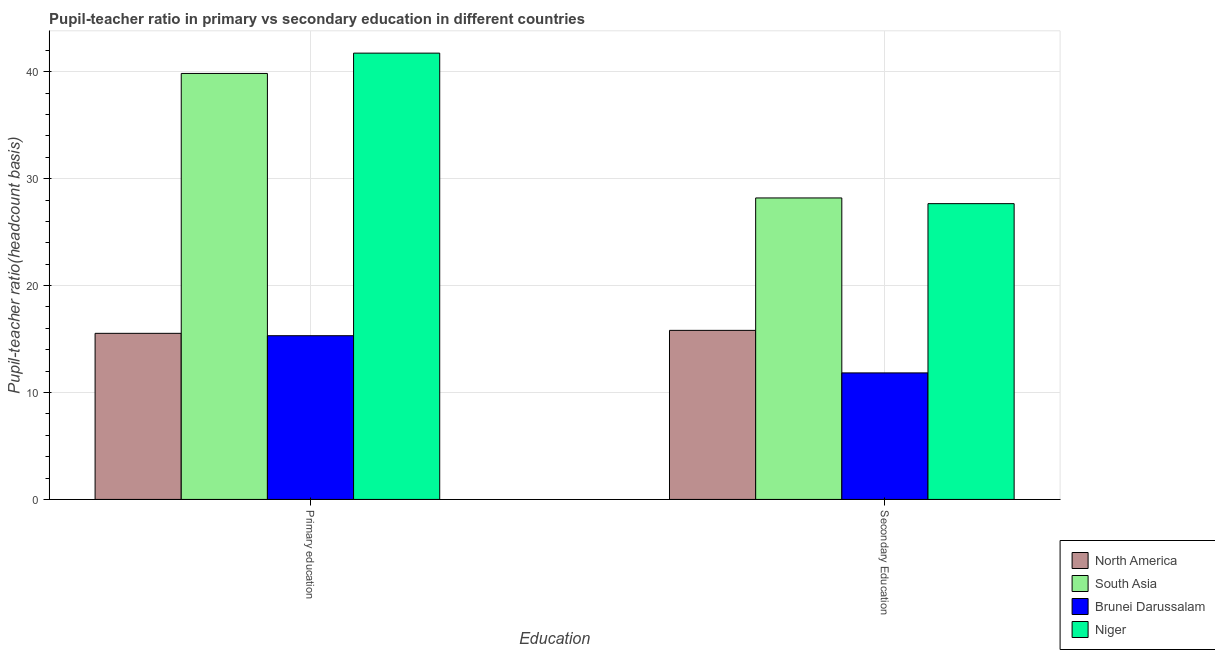Are the number of bars on each tick of the X-axis equal?
Provide a short and direct response. Yes. What is the label of the 2nd group of bars from the left?
Offer a terse response. Secondary Education. What is the pupil teacher ratio on secondary education in South Asia?
Keep it short and to the point. 28.19. Across all countries, what is the maximum pupil-teacher ratio in primary education?
Offer a terse response. 41.74. Across all countries, what is the minimum pupil teacher ratio on secondary education?
Give a very brief answer. 11.83. In which country was the pupil teacher ratio on secondary education minimum?
Provide a short and direct response. Brunei Darussalam. What is the total pupil-teacher ratio in primary education in the graph?
Keep it short and to the point. 112.41. What is the difference between the pupil teacher ratio on secondary education in Niger and that in Brunei Darussalam?
Provide a short and direct response. 15.83. What is the difference between the pupil-teacher ratio in primary education in Niger and the pupil teacher ratio on secondary education in Brunei Darussalam?
Your response must be concise. 29.9. What is the average pupil teacher ratio on secondary education per country?
Your answer should be compact. 20.87. What is the difference between the pupil teacher ratio on secondary education and pupil-teacher ratio in primary education in Brunei Darussalam?
Your answer should be very brief. -3.48. In how many countries, is the pupil-teacher ratio in primary education greater than 12 ?
Make the answer very short. 4. What is the ratio of the pupil teacher ratio on secondary education in Niger to that in South Asia?
Keep it short and to the point. 0.98. What does the 3rd bar from the left in Primary education represents?
Provide a short and direct response. Brunei Darussalam. What does the 1st bar from the right in Primary education represents?
Your response must be concise. Niger. How many bars are there?
Provide a succinct answer. 8. Are all the bars in the graph horizontal?
Give a very brief answer. No. Are the values on the major ticks of Y-axis written in scientific E-notation?
Make the answer very short. No. Does the graph contain any zero values?
Your answer should be very brief. No. How are the legend labels stacked?
Your answer should be very brief. Vertical. What is the title of the graph?
Keep it short and to the point. Pupil-teacher ratio in primary vs secondary education in different countries. Does "North America" appear as one of the legend labels in the graph?
Your answer should be compact. Yes. What is the label or title of the X-axis?
Your response must be concise. Education. What is the label or title of the Y-axis?
Your answer should be very brief. Pupil-teacher ratio(headcount basis). What is the Pupil-teacher ratio(headcount basis) of North America in Primary education?
Provide a short and direct response. 15.53. What is the Pupil-teacher ratio(headcount basis) of South Asia in Primary education?
Give a very brief answer. 39.84. What is the Pupil-teacher ratio(headcount basis) of Brunei Darussalam in Primary education?
Offer a terse response. 15.31. What is the Pupil-teacher ratio(headcount basis) of Niger in Primary education?
Your answer should be compact. 41.74. What is the Pupil-teacher ratio(headcount basis) in North America in Secondary Education?
Offer a very short reply. 15.81. What is the Pupil-teacher ratio(headcount basis) in South Asia in Secondary Education?
Make the answer very short. 28.19. What is the Pupil-teacher ratio(headcount basis) of Brunei Darussalam in Secondary Education?
Keep it short and to the point. 11.83. What is the Pupil-teacher ratio(headcount basis) in Niger in Secondary Education?
Your answer should be compact. 27.66. Across all Education, what is the maximum Pupil-teacher ratio(headcount basis) of North America?
Your answer should be very brief. 15.81. Across all Education, what is the maximum Pupil-teacher ratio(headcount basis) of South Asia?
Keep it short and to the point. 39.84. Across all Education, what is the maximum Pupil-teacher ratio(headcount basis) of Brunei Darussalam?
Offer a very short reply. 15.31. Across all Education, what is the maximum Pupil-teacher ratio(headcount basis) of Niger?
Ensure brevity in your answer.  41.74. Across all Education, what is the minimum Pupil-teacher ratio(headcount basis) in North America?
Give a very brief answer. 15.53. Across all Education, what is the minimum Pupil-teacher ratio(headcount basis) in South Asia?
Provide a short and direct response. 28.19. Across all Education, what is the minimum Pupil-teacher ratio(headcount basis) of Brunei Darussalam?
Your answer should be compact. 11.83. Across all Education, what is the minimum Pupil-teacher ratio(headcount basis) in Niger?
Provide a short and direct response. 27.66. What is the total Pupil-teacher ratio(headcount basis) in North America in the graph?
Offer a very short reply. 31.34. What is the total Pupil-teacher ratio(headcount basis) in South Asia in the graph?
Provide a short and direct response. 68.03. What is the total Pupil-teacher ratio(headcount basis) of Brunei Darussalam in the graph?
Your response must be concise. 27.14. What is the total Pupil-teacher ratio(headcount basis) of Niger in the graph?
Your answer should be compact. 69.4. What is the difference between the Pupil-teacher ratio(headcount basis) of North America in Primary education and that in Secondary Education?
Keep it short and to the point. -0.28. What is the difference between the Pupil-teacher ratio(headcount basis) of South Asia in Primary education and that in Secondary Education?
Keep it short and to the point. 11.64. What is the difference between the Pupil-teacher ratio(headcount basis) of Brunei Darussalam in Primary education and that in Secondary Education?
Make the answer very short. 3.48. What is the difference between the Pupil-teacher ratio(headcount basis) of Niger in Primary education and that in Secondary Education?
Provide a succinct answer. 14.07. What is the difference between the Pupil-teacher ratio(headcount basis) in North America in Primary education and the Pupil-teacher ratio(headcount basis) in South Asia in Secondary Education?
Ensure brevity in your answer.  -12.66. What is the difference between the Pupil-teacher ratio(headcount basis) in North America in Primary education and the Pupil-teacher ratio(headcount basis) in Brunei Darussalam in Secondary Education?
Provide a short and direct response. 3.7. What is the difference between the Pupil-teacher ratio(headcount basis) of North America in Primary education and the Pupil-teacher ratio(headcount basis) of Niger in Secondary Education?
Offer a very short reply. -12.13. What is the difference between the Pupil-teacher ratio(headcount basis) in South Asia in Primary education and the Pupil-teacher ratio(headcount basis) in Brunei Darussalam in Secondary Education?
Offer a terse response. 28. What is the difference between the Pupil-teacher ratio(headcount basis) in South Asia in Primary education and the Pupil-teacher ratio(headcount basis) in Niger in Secondary Education?
Ensure brevity in your answer.  12.18. What is the difference between the Pupil-teacher ratio(headcount basis) of Brunei Darussalam in Primary education and the Pupil-teacher ratio(headcount basis) of Niger in Secondary Education?
Provide a succinct answer. -12.35. What is the average Pupil-teacher ratio(headcount basis) in North America per Education?
Provide a short and direct response. 15.67. What is the average Pupil-teacher ratio(headcount basis) of South Asia per Education?
Your answer should be very brief. 34.01. What is the average Pupil-teacher ratio(headcount basis) of Brunei Darussalam per Education?
Offer a very short reply. 13.57. What is the average Pupil-teacher ratio(headcount basis) in Niger per Education?
Make the answer very short. 34.7. What is the difference between the Pupil-teacher ratio(headcount basis) of North America and Pupil-teacher ratio(headcount basis) of South Asia in Primary education?
Your answer should be compact. -24.3. What is the difference between the Pupil-teacher ratio(headcount basis) of North America and Pupil-teacher ratio(headcount basis) of Brunei Darussalam in Primary education?
Provide a short and direct response. 0.22. What is the difference between the Pupil-teacher ratio(headcount basis) of North America and Pupil-teacher ratio(headcount basis) of Niger in Primary education?
Give a very brief answer. -26.2. What is the difference between the Pupil-teacher ratio(headcount basis) of South Asia and Pupil-teacher ratio(headcount basis) of Brunei Darussalam in Primary education?
Your answer should be very brief. 24.53. What is the difference between the Pupil-teacher ratio(headcount basis) in South Asia and Pupil-teacher ratio(headcount basis) in Niger in Primary education?
Offer a terse response. -1.9. What is the difference between the Pupil-teacher ratio(headcount basis) in Brunei Darussalam and Pupil-teacher ratio(headcount basis) in Niger in Primary education?
Provide a succinct answer. -26.43. What is the difference between the Pupil-teacher ratio(headcount basis) in North America and Pupil-teacher ratio(headcount basis) in South Asia in Secondary Education?
Your answer should be very brief. -12.38. What is the difference between the Pupil-teacher ratio(headcount basis) in North America and Pupil-teacher ratio(headcount basis) in Brunei Darussalam in Secondary Education?
Your answer should be very brief. 3.98. What is the difference between the Pupil-teacher ratio(headcount basis) in North America and Pupil-teacher ratio(headcount basis) in Niger in Secondary Education?
Your response must be concise. -11.85. What is the difference between the Pupil-teacher ratio(headcount basis) of South Asia and Pupil-teacher ratio(headcount basis) of Brunei Darussalam in Secondary Education?
Give a very brief answer. 16.36. What is the difference between the Pupil-teacher ratio(headcount basis) of South Asia and Pupil-teacher ratio(headcount basis) of Niger in Secondary Education?
Your answer should be very brief. 0.53. What is the difference between the Pupil-teacher ratio(headcount basis) of Brunei Darussalam and Pupil-teacher ratio(headcount basis) of Niger in Secondary Education?
Offer a very short reply. -15.83. What is the ratio of the Pupil-teacher ratio(headcount basis) of North America in Primary education to that in Secondary Education?
Make the answer very short. 0.98. What is the ratio of the Pupil-teacher ratio(headcount basis) of South Asia in Primary education to that in Secondary Education?
Offer a very short reply. 1.41. What is the ratio of the Pupil-teacher ratio(headcount basis) in Brunei Darussalam in Primary education to that in Secondary Education?
Provide a short and direct response. 1.29. What is the ratio of the Pupil-teacher ratio(headcount basis) in Niger in Primary education to that in Secondary Education?
Your answer should be very brief. 1.51. What is the difference between the highest and the second highest Pupil-teacher ratio(headcount basis) in North America?
Provide a succinct answer. 0.28. What is the difference between the highest and the second highest Pupil-teacher ratio(headcount basis) of South Asia?
Your answer should be compact. 11.64. What is the difference between the highest and the second highest Pupil-teacher ratio(headcount basis) in Brunei Darussalam?
Provide a succinct answer. 3.48. What is the difference between the highest and the second highest Pupil-teacher ratio(headcount basis) of Niger?
Offer a terse response. 14.07. What is the difference between the highest and the lowest Pupil-teacher ratio(headcount basis) of North America?
Give a very brief answer. 0.28. What is the difference between the highest and the lowest Pupil-teacher ratio(headcount basis) of South Asia?
Offer a terse response. 11.64. What is the difference between the highest and the lowest Pupil-teacher ratio(headcount basis) of Brunei Darussalam?
Make the answer very short. 3.48. What is the difference between the highest and the lowest Pupil-teacher ratio(headcount basis) of Niger?
Offer a very short reply. 14.07. 